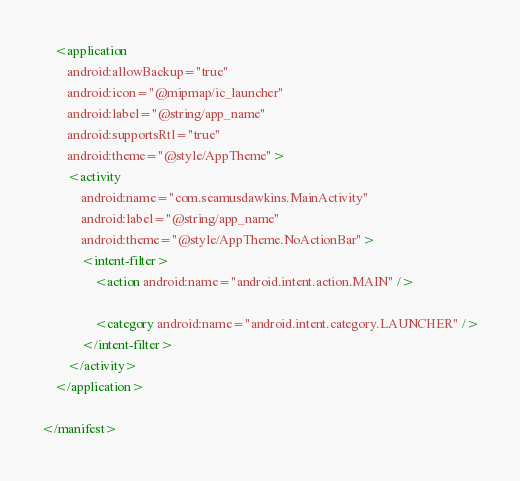Convert code to text. <code><loc_0><loc_0><loc_500><loc_500><_XML_>    <application
        android:allowBackup="true"
        android:icon="@mipmap/ic_launcher"
        android:label="@string/app_name"
        android:supportsRtl="true"
        android:theme="@style/AppTheme">
        <activity
            android:name="com.seamusdawkins.MainActivity"
            android:label="@string/app_name"
            android:theme="@style/AppTheme.NoActionBar">
            <intent-filter>
                <action android:name="android.intent.action.MAIN" />

                <category android:name="android.intent.category.LAUNCHER" />
            </intent-filter>
        </activity>
    </application>

</manifest>
</code> 